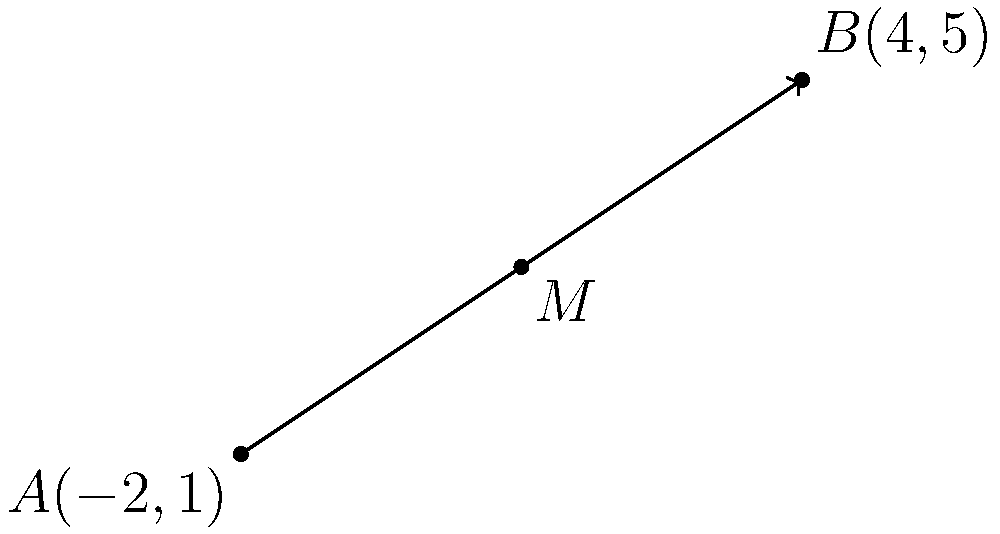Given the line segment with endpoints $A(-2,1)$ and $B(4,5)$, determine the coordinates of the midpoint $M$ using the conventional midpoint formula. Show your work using the standard algebraic method. To find the midpoint of a line segment, we use the conventional midpoint formula:

$M = (\frac{x_1 + x_2}{2}, \frac{y_1 + y_2}{2})$

Where $(x_1, y_1)$ are the coordinates of point $A$, and $(x_2, y_2)$ are the coordinates of point $B$.

Step 1: Identify the coordinates
$A(-2, 1)$, so $x_1 = -2$ and $y_1 = 1$
$B(4, 5)$, so $x_2 = 4$ and $y_2 = 5$

Step 2: Apply the midpoint formula for the x-coordinate
$x_M = \frac{x_1 + x_2}{2} = \frac{-2 + 4}{2} = \frac{2}{2} = 1$

Step 3: Apply the midpoint formula for the y-coordinate
$y_M = \frac{y_1 + y_2}{2} = \frac{1 + 5}{2} = \frac{6}{2} = 3$

Step 4: Combine the results
The midpoint $M$ has coordinates $(1, 3)$
Answer: $M(1, 3)$ 